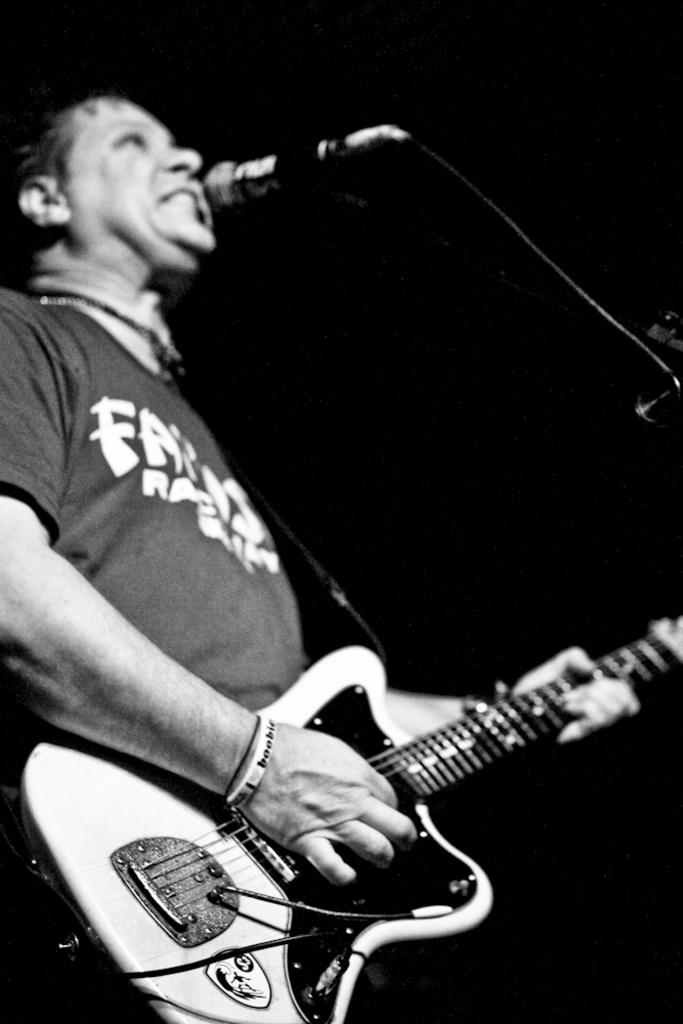What is the main subject of the image? There is a person in the image. Where is the person located in the image? The person is standing at the left side of the image. What is the person holding in his hands? The person is holding a guitar in his hands. What object is in front of the person? There is a microphone in front of the person. What activity is the person likely engaged in? It appears that the person is singing. What type of blade is being used by the person in the image? There is no blade present in the image; the person is holding a guitar and standing near a microphone. 